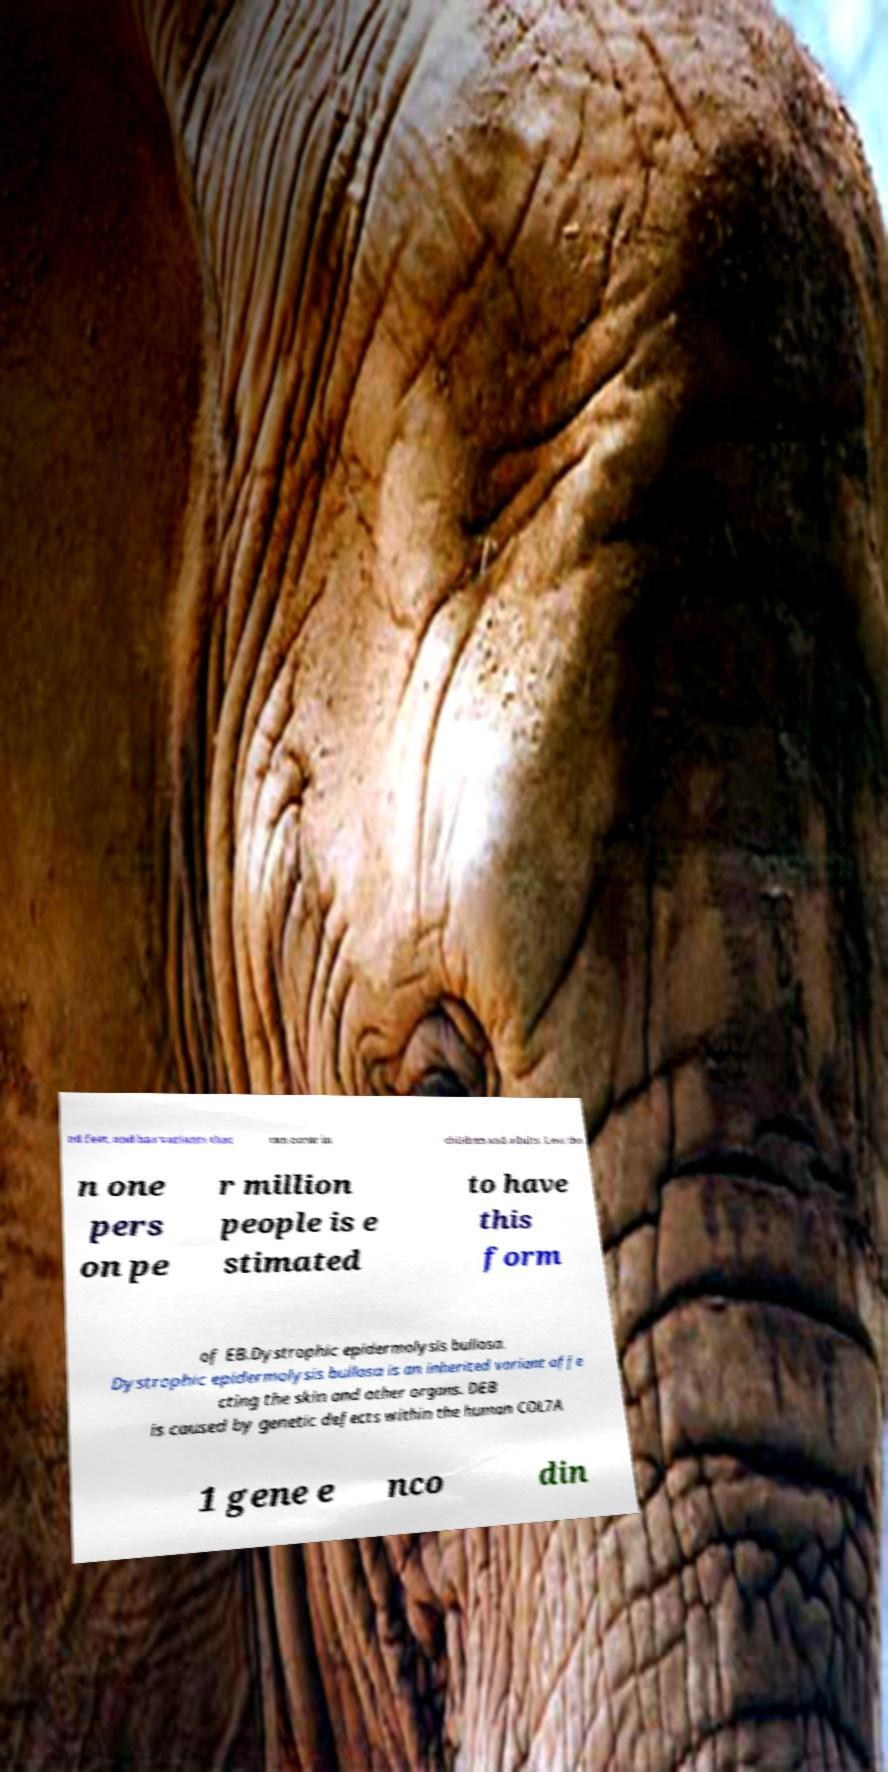Please read and relay the text visible in this image. What does it say? nd feet, and has variants that can occur in children and adults. Less tha n one pers on pe r million people is e stimated to have this form of EB.Dystrophic epidermolysis bullosa. Dystrophic epidermolysis bullosa is an inherited variant affe cting the skin and other organs. DEB is caused by genetic defects within the human COL7A 1 gene e nco din 